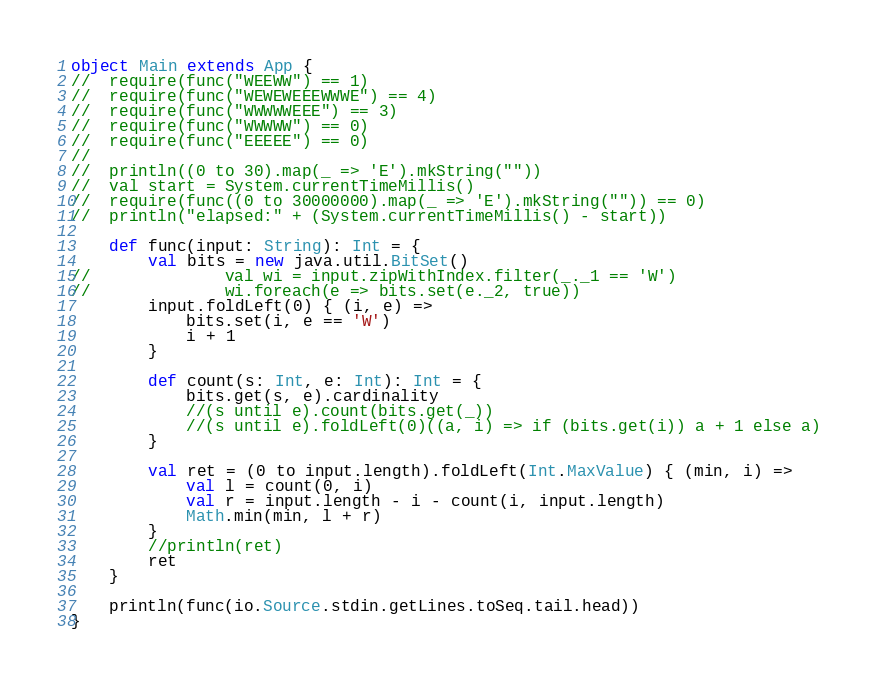<code> <loc_0><loc_0><loc_500><loc_500><_Scala_>object Main extends App {
//	require(func("WEEWW") == 1)
//	require(func("WEWEWEEEWWWE") == 4)
//	require(func("WWWWWEEE") == 3)
//	require(func("WWWWW") == 0)
//	require(func("EEEEE") == 0)
//
//	println((0 to 30).map(_ => 'E').mkString(""))
//	val start = System.currentTimeMillis()
//	require(func((0 to 30000000).map(_ => 'E').mkString("")) == 0)
//	println("elapsed:" + (System.currentTimeMillis() - start))

	def func(input: String): Int = {
		val bits = new java.util.BitSet()
//				val wi = input.zipWithIndex.filter(_._1 == 'W')
//				wi.foreach(e => bits.set(e._2, true))
		input.foldLeft(0) { (i, e) =>
			bits.set(i, e == 'W')
			i + 1
		}

		def count(s: Int, e: Int): Int = {
			bits.get(s, e).cardinality
			//(s until e).count(bits.get(_))
			//(s until e).foldLeft(0)((a, i) => if (bits.get(i)) a + 1 else a)
		}

		val ret = (0 to input.length).foldLeft(Int.MaxValue) { (min, i) =>
			val l = count(0, i)
			val r = input.length - i - count(i, input.length)
			Math.min(min, l + r)
		}
		//println(ret)
		ret
	}

	println(func(io.Source.stdin.getLines.toSeq.tail.head))
}</code> 